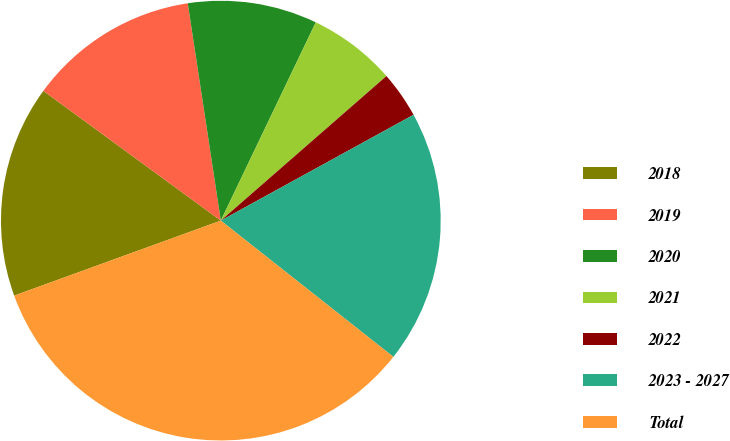Convert chart to OTSL. <chart><loc_0><loc_0><loc_500><loc_500><pie_chart><fcel>2018<fcel>2019<fcel>2020<fcel>2021<fcel>2022<fcel>2023 - 2027<fcel>Total<nl><fcel>15.59%<fcel>12.55%<fcel>9.51%<fcel>6.47%<fcel>3.43%<fcel>18.63%<fcel>33.82%<nl></chart> 